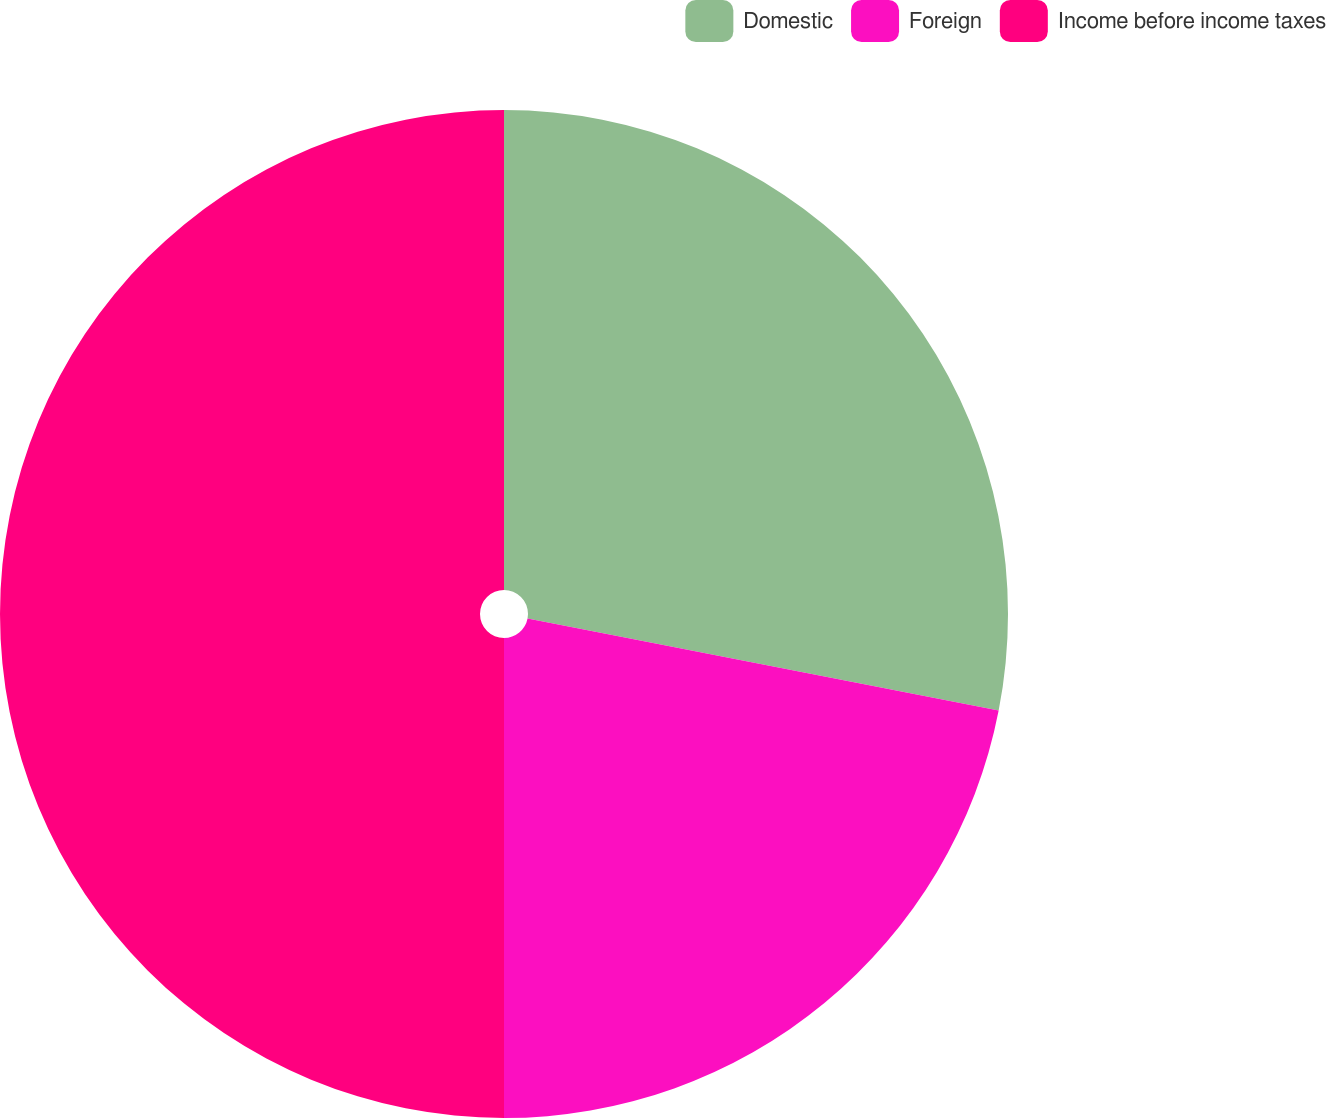Convert chart. <chart><loc_0><loc_0><loc_500><loc_500><pie_chart><fcel>Domestic<fcel>Foreign<fcel>Income before income taxes<nl><fcel>28.07%<fcel>21.93%<fcel>50.0%<nl></chart> 